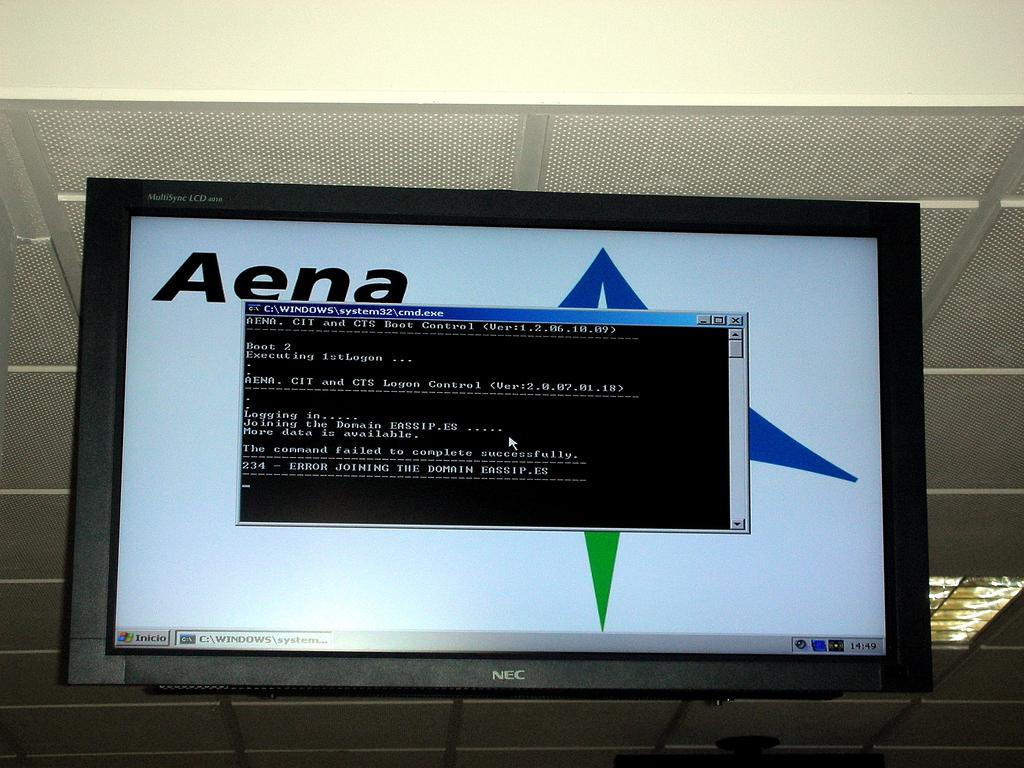<image>
Present a compact description of the photo's key features. On The screen behind the black box is written Aena. 